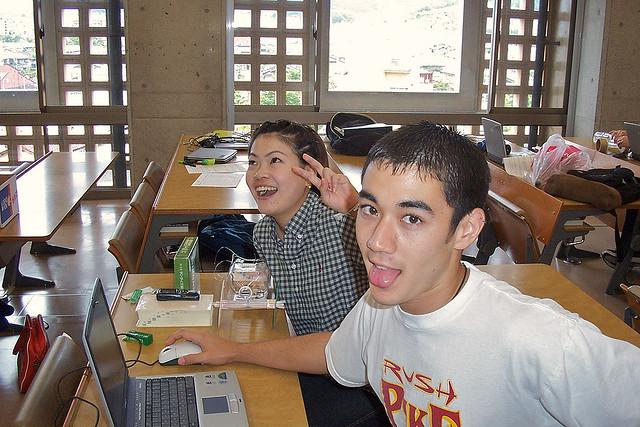Where are these young people seated? Please explain your reasoning. school. Young people are sitting in a room with a bunch of tables and chairs. 